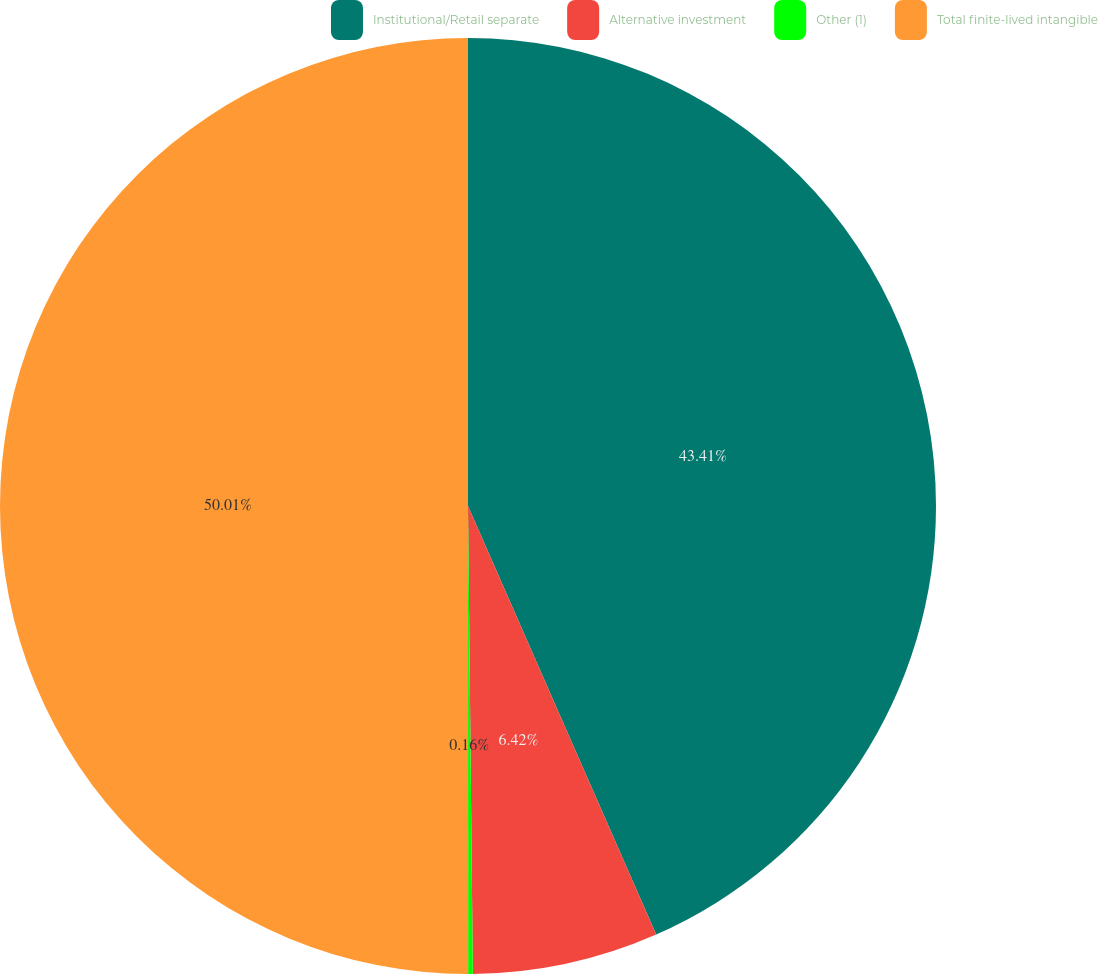Convert chart to OTSL. <chart><loc_0><loc_0><loc_500><loc_500><pie_chart><fcel>Institutional/Retail separate<fcel>Alternative investment<fcel>Other (1)<fcel>Total finite-lived intangible<nl><fcel>43.41%<fcel>6.42%<fcel>0.16%<fcel>50.0%<nl></chart> 